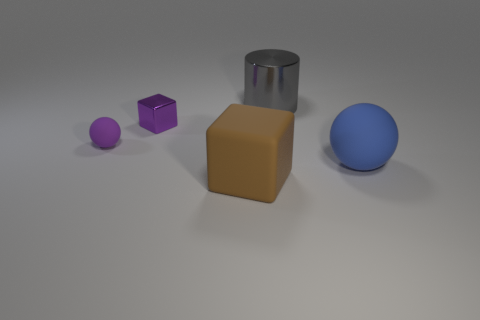Add 2 tiny red blocks. How many objects exist? 7 Subtract all balls. How many objects are left? 3 Add 1 purple objects. How many purple objects exist? 3 Subtract 0 yellow cylinders. How many objects are left? 5 Subtract all cylinders. Subtract all small metallic objects. How many objects are left? 3 Add 1 large matte spheres. How many large matte spheres are left? 2 